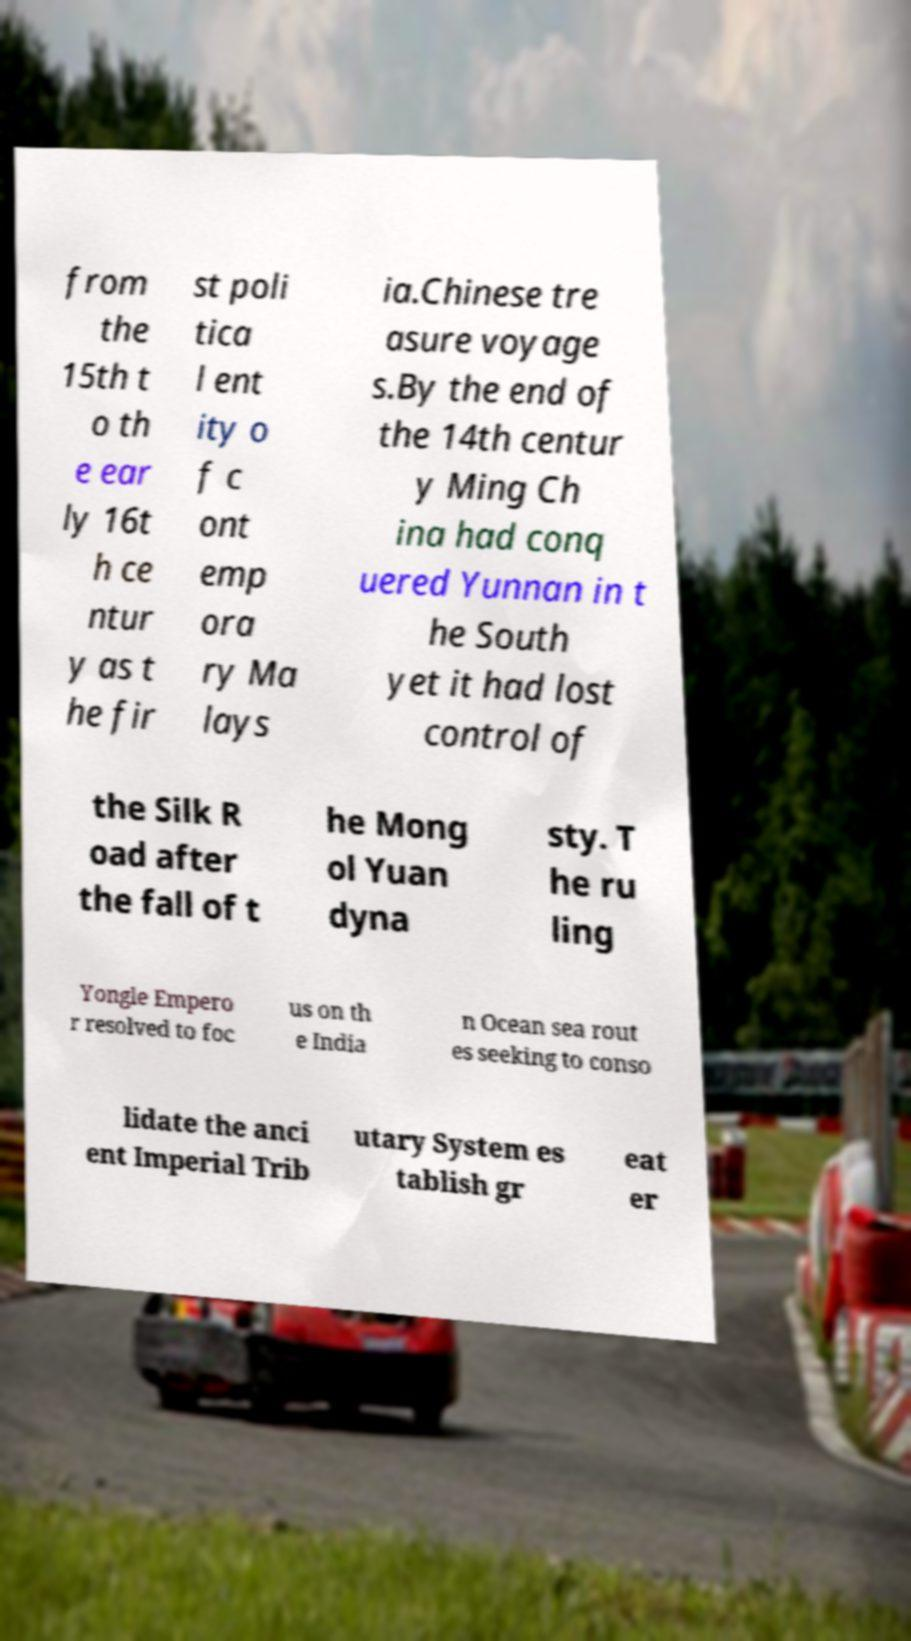There's text embedded in this image that I need extracted. Can you transcribe it verbatim? from the 15th t o th e ear ly 16t h ce ntur y as t he fir st poli tica l ent ity o f c ont emp ora ry Ma lays ia.Chinese tre asure voyage s.By the end of the 14th centur y Ming Ch ina had conq uered Yunnan in t he South yet it had lost control of the Silk R oad after the fall of t he Mong ol Yuan dyna sty. T he ru ling Yongle Empero r resolved to foc us on th e India n Ocean sea rout es seeking to conso lidate the anci ent Imperial Trib utary System es tablish gr eat er 